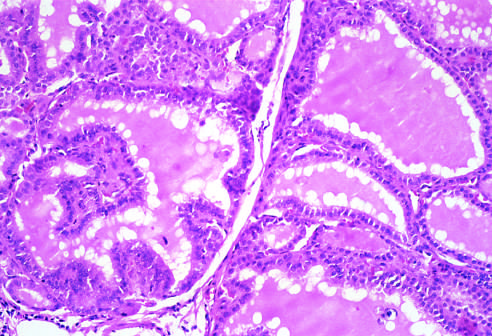re the follicles lined by tall columnar epithelial cells that are actively resorbing the colloid in the centers of the follicles, resulting in a scalloped appearance of the colloid?
Answer the question using a single word or phrase. Yes 